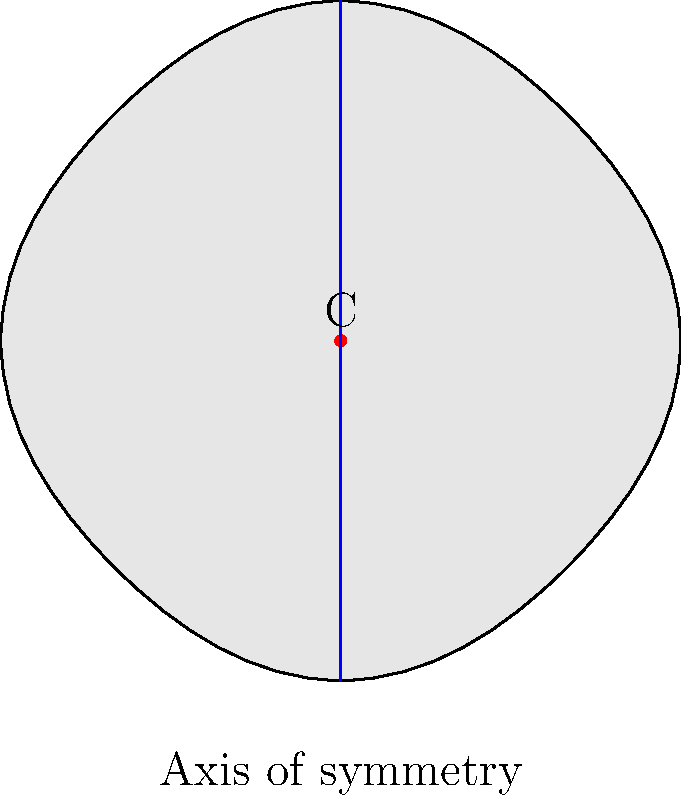Consider the simplified shape of a cello's body as shown in the figure. Point C represents the center of the cello. If we apply a reflection across the vertical axis of symmetry, what type of isometry is this operation, and how many times must it be applied to return the cello to its original position? To answer this question, let's analyze the symmetry operation step-by-step:

1. The operation described is a reflection across the vertical axis of symmetry (shown as a blue line in the figure).

2. Reflection is an isometry, which means it preserves distances and angles.

3. Specifically, reflection is an involutory isometry, meaning that when applied twice, it returns the object to its original position.

4. Properties of reflection:
   a) It changes the orientation of the object (like flipping it).
   b) It is its own inverse operation.

5. In group theory, this reflection belongs to the cyclic group of order 2, often denoted as $C_2$ or $\mathbb{Z}_2$.

6. To return the cello to its original position:
   - Applying the reflection once flips the cello.
   - Applying it a second time brings it back to the original position.

Therefore, the reflection must be applied twice (or any even number of times) to return the cello to its original position.
Answer: Involutory isometry; 2 times 